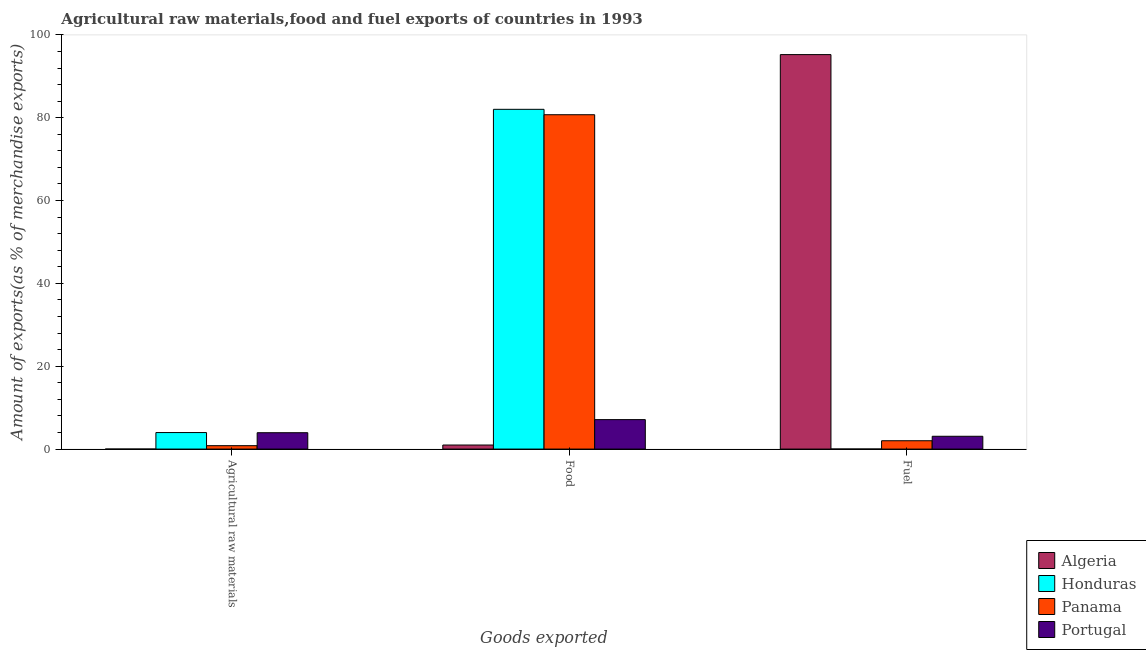How many groups of bars are there?
Give a very brief answer. 3. Are the number of bars per tick equal to the number of legend labels?
Your answer should be compact. Yes. Are the number of bars on each tick of the X-axis equal?
Make the answer very short. Yes. How many bars are there on the 3rd tick from the right?
Keep it short and to the point. 4. What is the label of the 2nd group of bars from the left?
Your answer should be very brief. Food. What is the percentage of food exports in Algeria?
Provide a short and direct response. 0.98. Across all countries, what is the maximum percentage of fuel exports?
Make the answer very short. 95.24. Across all countries, what is the minimum percentage of fuel exports?
Make the answer very short. 0.01. In which country was the percentage of raw materials exports maximum?
Provide a short and direct response. Honduras. In which country was the percentage of fuel exports minimum?
Offer a very short reply. Honduras. What is the total percentage of raw materials exports in the graph?
Provide a short and direct response. 8.76. What is the difference between the percentage of food exports in Algeria and that in Honduras?
Your answer should be very brief. -81.05. What is the difference between the percentage of food exports in Algeria and the percentage of raw materials exports in Panama?
Offer a terse response. 0.16. What is the average percentage of raw materials exports per country?
Keep it short and to the point. 2.19. What is the difference between the percentage of raw materials exports and percentage of fuel exports in Algeria?
Ensure brevity in your answer.  -95.24. What is the ratio of the percentage of food exports in Honduras to that in Portugal?
Ensure brevity in your answer.  11.54. Is the difference between the percentage of fuel exports in Panama and Algeria greater than the difference between the percentage of food exports in Panama and Algeria?
Offer a very short reply. No. What is the difference between the highest and the second highest percentage of food exports?
Offer a very short reply. 1.31. What is the difference between the highest and the lowest percentage of food exports?
Your response must be concise. 81.05. Is the sum of the percentage of food exports in Algeria and Panama greater than the maximum percentage of raw materials exports across all countries?
Offer a very short reply. Yes. What does the 3rd bar from the left in Agricultural raw materials represents?
Your response must be concise. Panama. What does the 4th bar from the right in Fuel represents?
Offer a very short reply. Algeria. How many countries are there in the graph?
Your answer should be very brief. 4. Are the values on the major ticks of Y-axis written in scientific E-notation?
Provide a short and direct response. No. Where does the legend appear in the graph?
Offer a very short reply. Bottom right. How are the legend labels stacked?
Make the answer very short. Vertical. What is the title of the graph?
Offer a terse response. Agricultural raw materials,food and fuel exports of countries in 1993. What is the label or title of the X-axis?
Offer a very short reply. Goods exported. What is the label or title of the Y-axis?
Offer a terse response. Amount of exports(as % of merchandise exports). What is the Amount of exports(as % of merchandise exports) in Algeria in Agricultural raw materials?
Offer a terse response. 0. What is the Amount of exports(as % of merchandise exports) in Honduras in Agricultural raw materials?
Your answer should be very brief. 3.99. What is the Amount of exports(as % of merchandise exports) in Panama in Agricultural raw materials?
Your response must be concise. 0.82. What is the Amount of exports(as % of merchandise exports) of Portugal in Agricultural raw materials?
Offer a terse response. 3.95. What is the Amount of exports(as % of merchandise exports) in Algeria in Food?
Provide a succinct answer. 0.98. What is the Amount of exports(as % of merchandise exports) in Honduras in Food?
Your response must be concise. 82.03. What is the Amount of exports(as % of merchandise exports) of Panama in Food?
Make the answer very short. 80.72. What is the Amount of exports(as % of merchandise exports) of Portugal in Food?
Give a very brief answer. 7.11. What is the Amount of exports(as % of merchandise exports) of Algeria in Fuel?
Give a very brief answer. 95.24. What is the Amount of exports(as % of merchandise exports) in Honduras in Fuel?
Provide a succinct answer. 0.01. What is the Amount of exports(as % of merchandise exports) of Panama in Fuel?
Make the answer very short. 2.01. What is the Amount of exports(as % of merchandise exports) in Portugal in Fuel?
Keep it short and to the point. 3.09. Across all Goods exported, what is the maximum Amount of exports(as % of merchandise exports) in Algeria?
Provide a succinct answer. 95.24. Across all Goods exported, what is the maximum Amount of exports(as % of merchandise exports) in Honduras?
Keep it short and to the point. 82.03. Across all Goods exported, what is the maximum Amount of exports(as % of merchandise exports) in Panama?
Ensure brevity in your answer.  80.72. Across all Goods exported, what is the maximum Amount of exports(as % of merchandise exports) of Portugal?
Ensure brevity in your answer.  7.11. Across all Goods exported, what is the minimum Amount of exports(as % of merchandise exports) in Algeria?
Give a very brief answer. 0. Across all Goods exported, what is the minimum Amount of exports(as % of merchandise exports) of Honduras?
Your response must be concise. 0.01. Across all Goods exported, what is the minimum Amount of exports(as % of merchandise exports) of Panama?
Ensure brevity in your answer.  0.82. Across all Goods exported, what is the minimum Amount of exports(as % of merchandise exports) in Portugal?
Provide a succinct answer. 3.09. What is the total Amount of exports(as % of merchandise exports) of Algeria in the graph?
Provide a short and direct response. 96.22. What is the total Amount of exports(as % of merchandise exports) of Honduras in the graph?
Provide a succinct answer. 86.03. What is the total Amount of exports(as % of merchandise exports) in Panama in the graph?
Provide a short and direct response. 83.55. What is the total Amount of exports(as % of merchandise exports) of Portugal in the graph?
Ensure brevity in your answer.  14.15. What is the difference between the Amount of exports(as % of merchandise exports) in Algeria in Agricultural raw materials and that in Food?
Ensure brevity in your answer.  -0.98. What is the difference between the Amount of exports(as % of merchandise exports) of Honduras in Agricultural raw materials and that in Food?
Ensure brevity in your answer.  -78.04. What is the difference between the Amount of exports(as % of merchandise exports) of Panama in Agricultural raw materials and that in Food?
Offer a very short reply. -79.9. What is the difference between the Amount of exports(as % of merchandise exports) in Portugal in Agricultural raw materials and that in Food?
Provide a short and direct response. -3.16. What is the difference between the Amount of exports(as % of merchandise exports) of Algeria in Agricultural raw materials and that in Fuel?
Keep it short and to the point. -95.24. What is the difference between the Amount of exports(as % of merchandise exports) of Honduras in Agricultural raw materials and that in Fuel?
Ensure brevity in your answer.  3.98. What is the difference between the Amount of exports(as % of merchandise exports) of Panama in Agricultural raw materials and that in Fuel?
Provide a short and direct response. -1.19. What is the difference between the Amount of exports(as % of merchandise exports) in Portugal in Agricultural raw materials and that in Fuel?
Provide a short and direct response. 0.86. What is the difference between the Amount of exports(as % of merchandise exports) of Algeria in Food and that in Fuel?
Provide a succinct answer. -94.26. What is the difference between the Amount of exports(as % of merchandise exports) in Honduras in Food and that in Fuel?
Keep it short and to the point. 82.02. What is the difference between the Amount of exports(as % of merchandise exports) of Panama in Food and that in Fuel?
Keep it short and to the point. 78.71. What is the difference between the Amount of exports(as % of merchandise exports) of Portugal in Food and that in Fuel?
Keep it short and to the point. 4.02. What is the difference between the Amount of exports(as % of merchandise exports) of Algeria in Agricultural raw materials and the Amount of exports(as % of merchandise exports) of Honduras in Food?
Your response must be concise. -82.03. What is the difference between the Amount of exports(as % of merchandise exports) in Algeria in Agricultural raw materials and the Amount of exports(as % of merchandise exports) in Panama in Food?
Make the answer very short. -80.72. What is the difference between the Amount of exports(as % of merchandise exports) in Algeria in Agricultural raw materials and the Amount of exports(as % of merchandise exports) in Portugal in Food?
Provide a short and direct response. -7.11. What is the difference between the Amount of exports(as % of merchandise exports) of Honduras in Agricultural raw materials and the Amount of exports(as % of merchandise exports) of Panama in Food?
Your response must be concise. -76.74. What is the difference between the Amount of exports(as % of merchandise exports) of Honduras in Agricultural raw materials and the Amount of exports(as % of merchandise exports) of Portugal in Food?
Give a very brief answer. -3.12. What is the difference between the Amount of exports(as % of merchandise exports) of Panama in Agricultural raw materials and the Amount of exports(as % of merchandise exports) of Portugal in Food?
Provide a succinct answer. -6.29. What is the difference between the Amount of exports(as % of merchandise exports) of Algeria in Agricultural raw materials and the Amount of exports(as % of merchandise exports) of Honduras in Fuel?
Make the answer very short. -0.01. What is the difference between the Amount of exports(as % of merchandise exports) of Algeria in Agricultural raw materials and the Amount of exports(as % of merchandise exports) of Panama in Fuel?
Offer a terse response. -2.01. What is the difference between the Amount of exports(as % of merchandise exports) in Algeria in Agricultural raw materials and the Amount of exports(as % of merchandise exports) in Portugal in Fuel?
Provide a succinct answer. -3.09. What is the difference between the Amount of exports(as % of merchandise exports) of Honduras in Agricultural raw materials and the Amount of exports(as % of merchandise exports) of Panama in Fuel?
Give a very brief answer. 1.98. What is the difference between the Amount of exports(as % of merchandise exports) in Honduras in Agricultural raw materials and the Amount of exports(as % of merchandise exports) in Portugal in Fuel?
Make the answer very short. 0.9. What is the difference between the Amount of exports(as % of merchandise exports) in Panama in Agricultural raw materials and the Amount of exports(as % of merchandise exports) in Portugal in Fuel?
Provide a short and direct response. -2.27. What is the difference between the Amount of exports(as % of merchandise exports) of Algeria in Food and the Amount of exports(as % of merchandise exports) of Honduras in Fuel?
Your response must be concise. 0.97. What is the difference between the Amount of exports(as % of merchandise exports) of Algeria in Food and the Amount of exports(as % of merchandise exports) of Panama in Fuel?
Your response must be concise. -1.03. What is the difference between the Amount of exports(as % of merchandise exports) in Algeria in Food and the Amount of exports(as % of merchandise exports) in Portugal in Fuel?
Provide a short and direct response. -2.11. What is the difference between the Amount of exports(as % of merchandise exports) in Honduras in Food and the Amount of exports(as % of merchandise exports) in Panama in Fuel?
Keep it short and to the point. 80.02. What is the difference between the Amount of exports(as % of merchandise exports) in Honduras in Food and the Amount of exports(as % of merchandise exports) in Portugal in Fuel?
Offer a very short reply. 78.94. What is the difference between the Amount of exports(as % of merchandise exports) of Panama in Food and the Amount of exports(as % of merchandise exports) of Portugal in Fuel?
Your response must be concise. 77.63. What is the average Amount of exports(as % of merchandise exports) in Algeria per Goods exported?
Provide a short and direct response. 32.07. What is the average Amount of exports(as % of merchandise exports) of Honduras per Goods exported?
Ensure brevity in your answer.  28.68. What is the average Amount of exports(as % of merchandise exports) in Panama per Goods exported?
Your response must be concise. 27.85. What is the average Amount of exports(as % of merchandise exports) of Portugal per Goods exported?
Keep it short and to the point. 4.72. What is the difference between the Amount of exports(as % of merchandise exports) in Algeria and Amount of exports(as % of merchandise exports) in Honduras in Agricultural raw materials?
Your answer should be compact. -3.99. What is the difference between the Amount of exports(as % of merchandise exports) in Algeria and Amount of exports(as % of merchandise exports) in Panama in Agricultural raw materials?
Provide a succinct answer. -0.82. What is the difference between the Amount of exports(as % of merchandise exports) of Algeria and Amount of exports(as % of merchandise exports) of Portugal in Agricultural raw materials?
Your answer should be very brief. -3.95. What is the difference between the Amount of exports(as % of merchandise exports) in Honduras and Amount of exports(as % of merchandise exports) in Panama in Agricultural raw materials?
Your answer should be very brief. 3.17. What is the difference between the Amount of exports(as % of merchandise exports) in Honduras and Amount of exports(as % of merchandise exports) in Portugal in Agricultural raw materials?
Provide a succinct answer. 0.04. What is the difference between the Amount of exports(as % of merchandise exports) in Panama and Amount of exports(as % of merchandise exports) in Portugal in Agricultural raw materials?
Your answer should be very brief. -3.13. What is the difference between the Amount of exports(as % of merchandise exports) of Algeria and Amount of exports(as % of merchandise exports) of Honduras in Food?
Keep it short and to the point. -81.05. What is the difference between the Amount of exports(as % of merchandise exports) of Algeria and Amount of exports(as % of merchandise exports) of Panama in Food?
Provide a short and direct response. -79.74. What is the difference between the Amount of exports(as % of merchandise exports) of Algeria and Amount of exports(as % of merchandise exports) of Portugal in Food?
Provide a succinct answer. -6.13. What is the difference between the Amount of exports(as % of merchandise exports) of Honduras and Amount of exports(as % of merchandise exports) of Panama in Food?
Your response must be concise. 1.31. What is the difference between the Amount of exports(as % of merchandise exports) of Honduras and Amount of exports(as % of merchandise exports) of Portugal in Food?
Provide a short and direct response. 74.92. What is the difference between the Amount of exports(as % of merchandise exports) of Panama and Amount of exports(as % of merchandise exports) of Portugal in Food?
Offer a very short reply. 73.61. What is the difference between the Amount of exports(as % of merchandise exports) of Algeria and Amount of exports(as % of merchandise exports) of Honduras in Fuel?
Offer a terse response. 95.23. What is the difference between the Amount of exports(as % of merchandise exports) in Algeria and Amount of exports(as % of merchandise exports) in Panama in Fuel?
Offer a very short reply. 93.23. What is the difference between the Amount of exports(as % of merchandise exports) of Algeria and Amount of exports(as % of merchandise exports) of Portugal in Fuel?
Ensure brevity in your answer.  92.15. What is the difference between the Amount of exports(as % of merchandise exports) of Honduras and Amount of exports(as % of merchandise exports) of Panama in Fuel?
Give a very brief answer. -2. What is the difference between the Amount of exports(as % of merchandise exports) in Honduras and Amount of exports(as % of merchandise exports) in Portugal in Fuel?
Your answer should be very brief. -3.08. What is the difference between the Amount of exports(as % of merchandise exports) in Panama and Amount of exports(as % of merchandise exports) in Portugal in Fuel?
Your answer should be compact. -1.08. What is the ratio of the Amount of exports(as % of merchandise exports) of Algeria in Agricultural raw materials to that in Food?
Your answer should be very brief. 0. What is the ratio of the Amount of exports(as % of merchandise exports) of Honduras in Agricultural raw materials to that in Food?
Provide a short and direct response. 0.05. What is the ratio of the Amount of exports(as % of merchandise exports) of Panama in Agricultural raw materials to that in Food?
Your answer should be very brief. 0.01. What is the ratio of the Amount of exports(as % of merchandise exports) in Portugal in Agricultural raw materials to that in Food?
Your answer should be compact. 0.56. What is the ratio of the Amount of exports(as % of merchandise exports) in Algeria in Agricultural raw materials to that in Fuel?
Provide a short and direct response. 0. What is the ratio of the Amount of exports(as % of merchandise exports) of Honduras in Agricultural raw materials to that in Fuel?
Keep it short and to the point. 375.92. What is the ratio of the Amount of exports(as % of merchandise exports) of Panama in Agricultural raw materials to that in Fuel?
Your response must be concise. 0.41. What is the ratio of the Amount of exports(as % of merchandise exports) in Portugal in Agricultural raw materials to that in Fuel?
Keep it short and to the point. 1.28. What is the ratio of the Amount of exports(as % of merchandise exports) in Algeria in Food to that in Fuel?
Your answer should be very brief. 0.01. What is the ratio of the Amount of exports(as % of merchandise exports) in Honduras in Food to that in Fuel?
Ensure brevity in your answer.  7732.83. What is the ratio of the Amount of exports(as % of merchandise exports) of Panama in Food to that in Fuel?
Keep it short and to the point. 40.14. What is the ratio of the Amount of exports(as % of merchandise exports) in Portugal in Food to that in Fuel?
Your response must be concise. 2.3. What is the difference between the highest and the second highest Amount of exports(as % of merchandise exports) of Algeria?
Offer a terse response. 94.26. What is the difference between the highest and the second highest Amount of exports(as % of merchandise exports) in Honduras?
Your answer should be very brief. 78.04. What is the difference between the highest and the second highest Amount of exports(as % of merchandise exports) of Panama?
Make the answer very short. 78.71. What is the difference between the highest and the second highest Amount of exports(as % of merchandise exports) in Portugal?
Your answer should be compact. 3.16. What is the difference between the highest and the lowest Amount of exports(as % of merchandise exports) in Algeria?
Your answer should be very brief. 95.24. What is the difference between the highest and the lowest Amount of exports(as % of merchandise exports) of Honduras?
Give a very brief answer. 82.02. What is the difference between the highest and the lowest Amount of exports(as % of merchandise exports) of Panama?
Ensure brevity in your answer.  79.9. What is the difference between the highest and the lowest Amount of exports(as % of merchandise exports) of Portugal?
Offer a terse response. 4.02. 